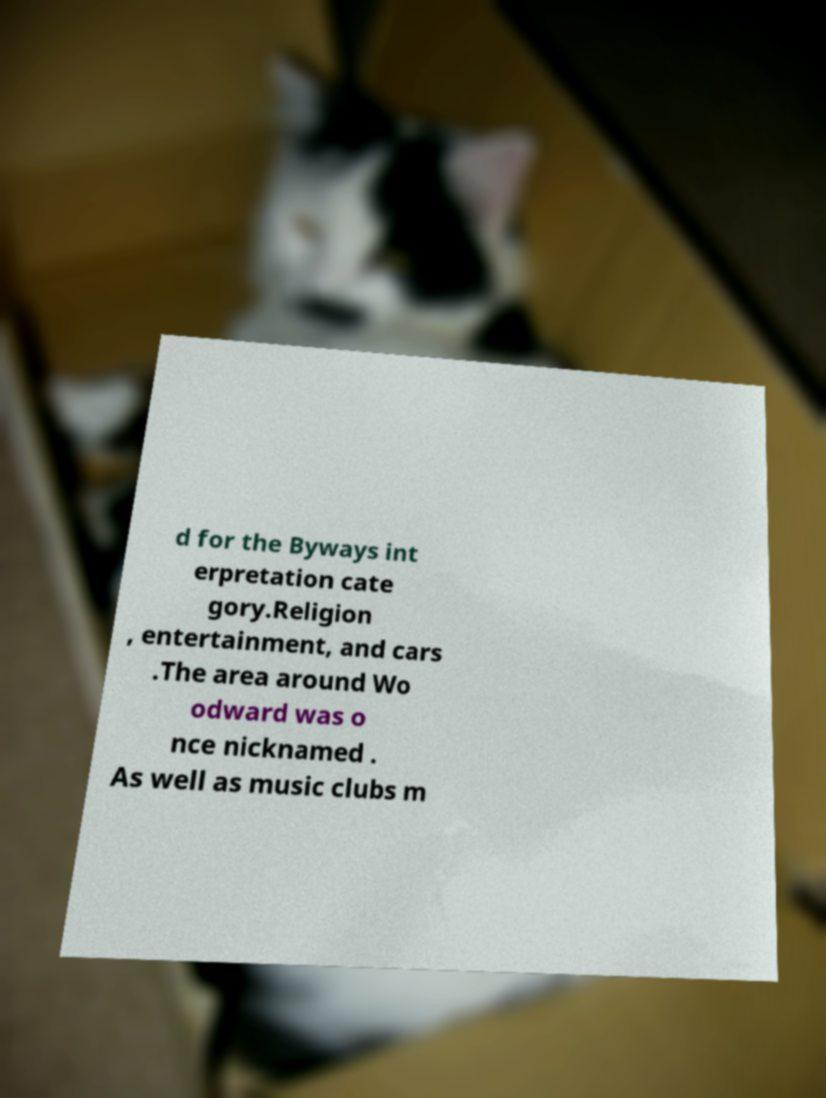Please identify and transcribe the text found in this image. d for the Byways int erpretation cate gory.Religion , entertainment, and cars .The area around Wo odward was o nce nicknamed . As well as music clubs m 